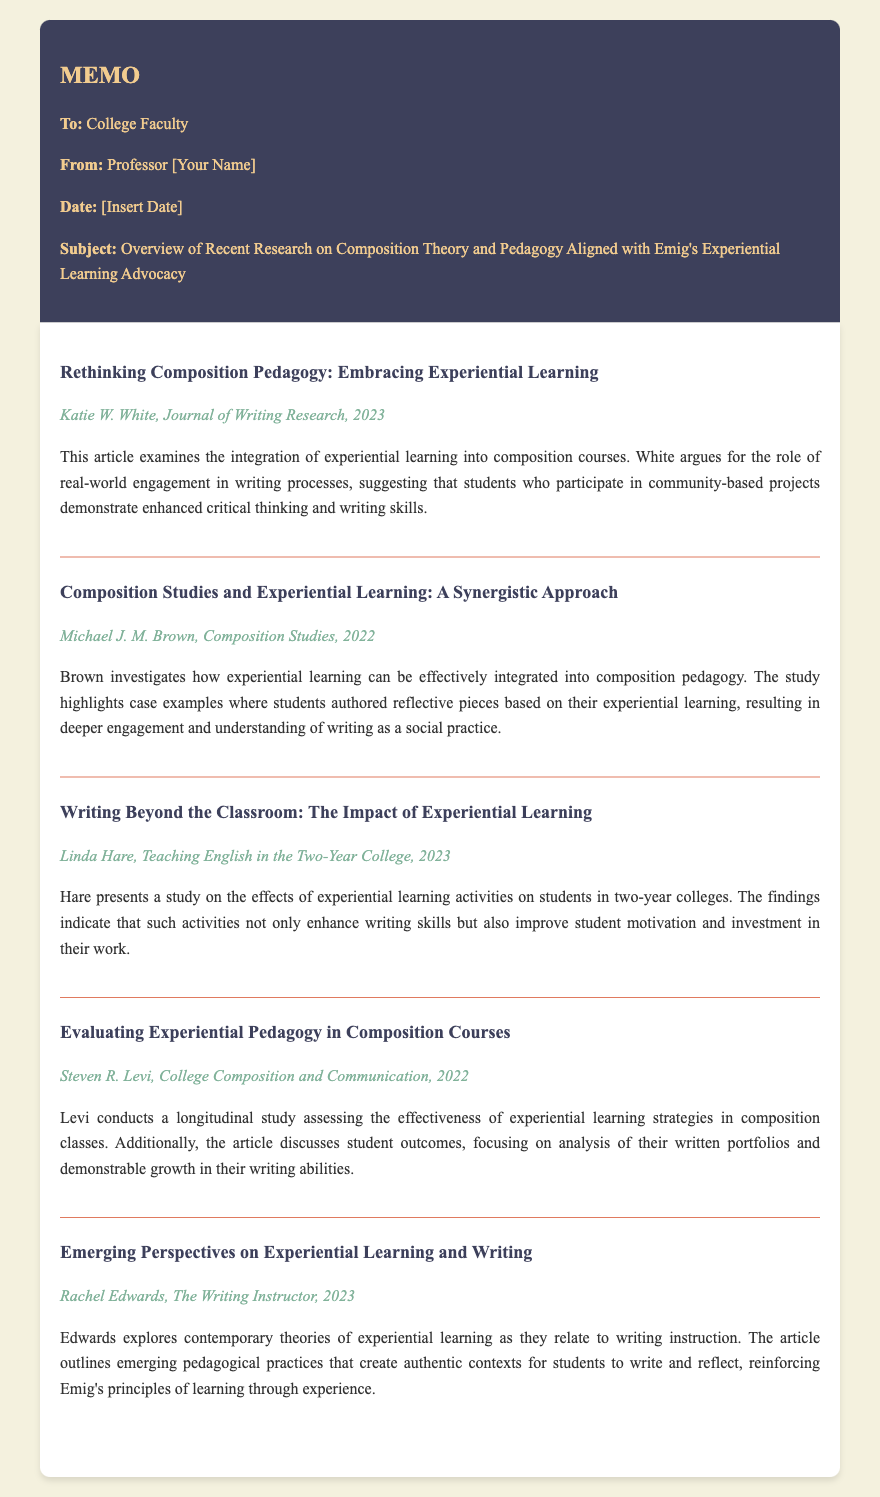What is the title of the first article? The title of the first article is found in the memo under the article section.
Answer: Rethinking Composition Pedagogy: Embracing Experiential Learning Who authored the article titled "Composition Studies and Experiential Learning: A Synergistic Approach"? The author's name can be located in the metadata section of the specified article.
Answer: Michael J. M. Brown In what year was the article "Writing Beyond the Classroom: The Impact of Experiential Learning" published? The publication year is specified in the metadata of the article.
Answer: 2023 How many articles are listed in the memo? The number of articles is counted by reviewing the article sections in the document.
Answer: Five What pedagogical approach does Rachel Edwards discuss in her article? The approach discussed by Edwards is mentioned in the summary of her article.
Answer: Experiential learning Which article presents a longitudinal study? The article discussing a longitudinal study is identified by reviewing the summaries for specific study details.
Answer: Evaluating Experiential Pedagogy in Composition Courses What is the main focus of Linda Hare's article? The focus can be deduced from the summary of Hare's article provided in the memo.
Answer: Effects of experiential learning activities Who is the intended audience of the memo? The intended audience can be found in the introductory section of the memo.
Answer: College Faculty 